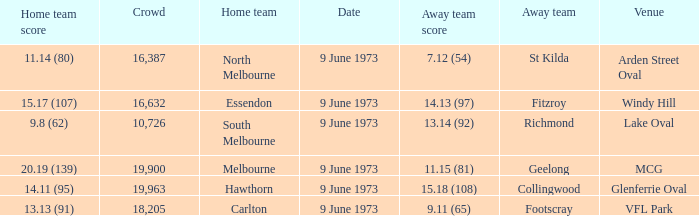Could you parse the entire table as a dict? {'header': ['Home team score', 'Crowd', 'Home team', 'Date', 'Away team score', 'Away team', 'Venue'], 'rows': [['11.14 (80)', '16,387', 'North Melbourne', '9 June 1973', '7.12 (54)', 'St Kilda', 'Arden Street Oval'], ['15.17 (107)', '16,632', 'Essendon', '9 June 1973', '14.13 (97)', 'Fitzroy', 'Windy Hill'], ['9.8 (62)', '10,726', 'South Melbourne', '9 June 1973', '13.14 (92)', 'Richmond', 'Lake Oval'], ['20.19 (139)', '19,900', 'Melbourne', '9 June 1973', '11.15 (81)', 'Geelong', 'MCG'], ['14.11 (95)', '19,963', 'Hawthorn', '9 June 1973', '15.18 (108)', 'Collingwood', 'Glenferrie Oval'], ['13.13 (91)', '18,205', 'Carlton', '9 June 1973', '9.11 (65)', 'Footscray', 'VFL Park']]} What was North Melbourne's score as the home team? 11.14 (80). 